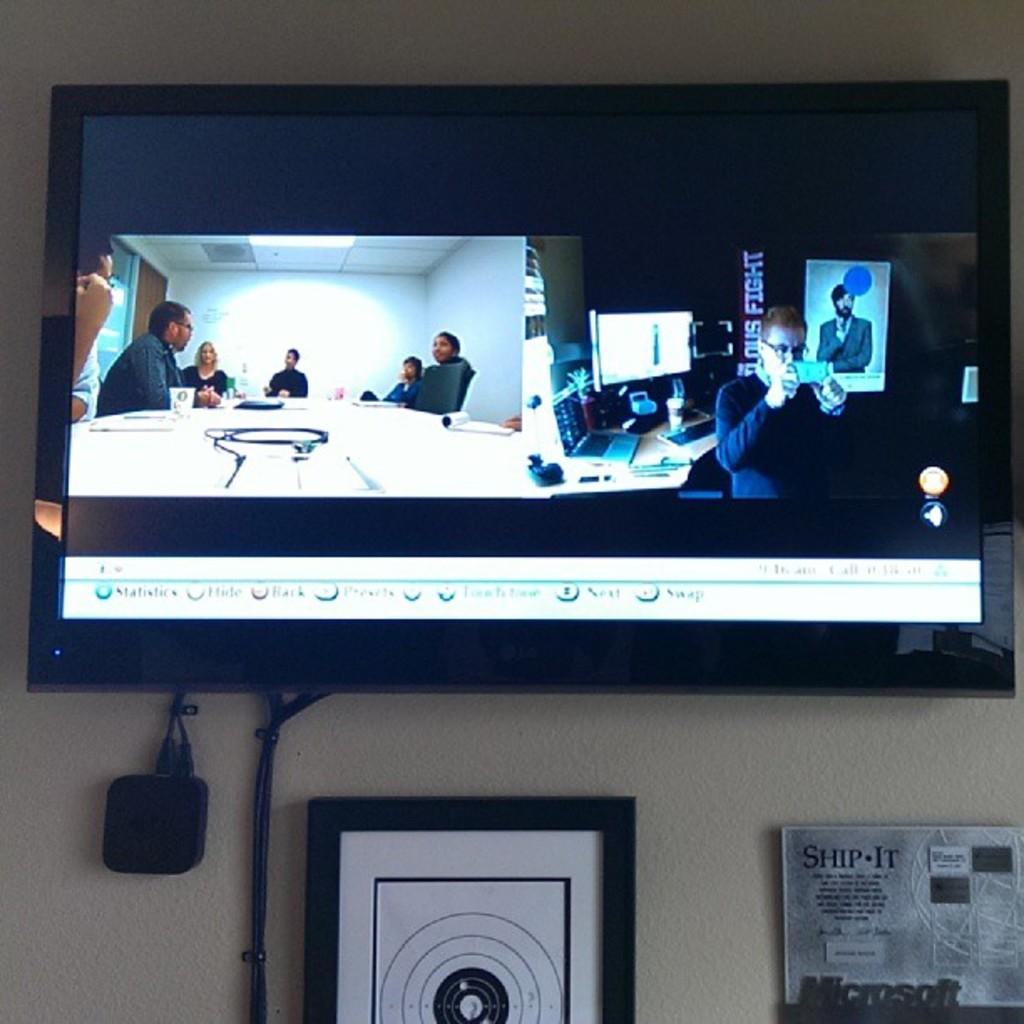<image>
Write a terse but informative summary of the picture. An LG brand tv with a split screen showing two things. 